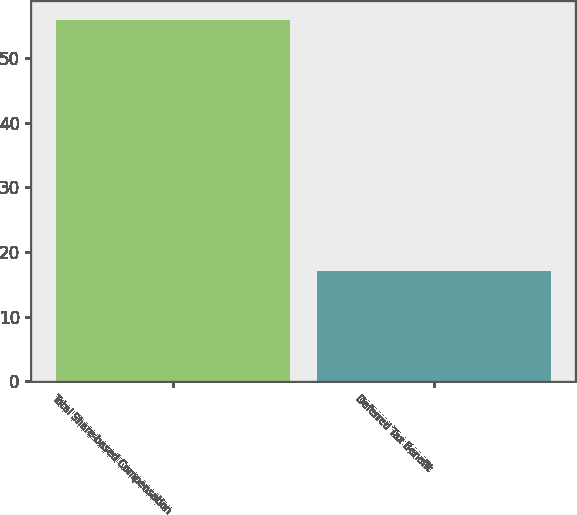Convert chart to OTSL. <chart><loc_0><loc_0><loc_500><loc_500><bar_chart><fcel>Total Share-based Compensation<fcel>Deferred Tax Benefit<nl><fcel>56<fcel>17<nl></chart> 